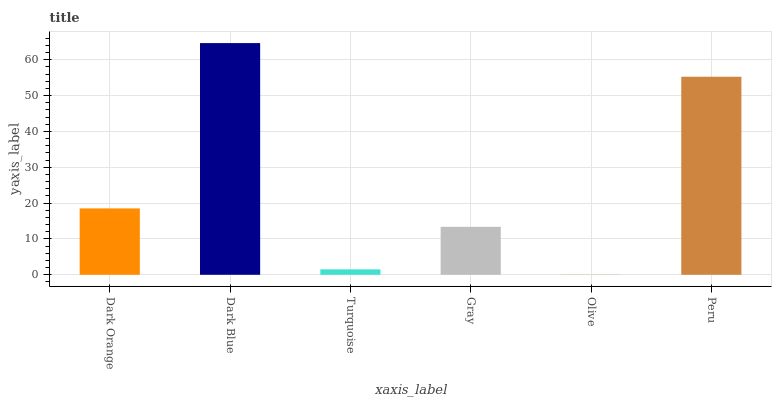Is Olive the minimum?
Answer yes or no. Yes. Is Dark Blue the maximum?
Answer yes or no. Yes. Is Turquoise the minimum?
Answer yes or no. No. Is Turquoise the maximum?
Answer yes or no. No. Is Dark Blue greater than Turquoise?
Answer yes or no. Yes. Is Turquoise less than Dark Blue?
Answer yes or no. Yes. Is Turquoise greater than Dark Blue?
Answer yes or no. No. Is Dark Blue less than Turquoise?
Answer yes or no. No. Is Dark Orange the high median?
Answer yes or no. Yes. Is Gray the low median?
Answer yes or no. Yes. Is Gray the high median?
Answer yes or no. No. Is Turquoise the low median?
Answer yes or no. No. 